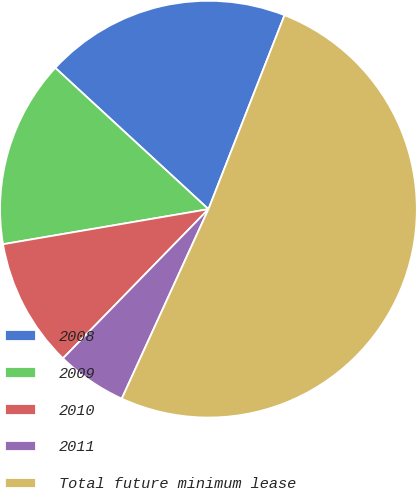<chart> <loc_0><loc_0><loc_500><loc_500><pie_chart><fcel>2008<fcel>2009<fcel>2010<fcel>2011<fcel>Total future minimum lease<nl><fcel>19.09%<fcel>14.55%<fcel>10.01%<fcel>5.47%<fcel>50.88%<nl></chart> 